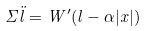<formula> <loc_0><loc_0><loc_500><loc_500>\Sigma \ddot { l } = W ^ { \prime } ( l - \alpha | x | )</formula> 